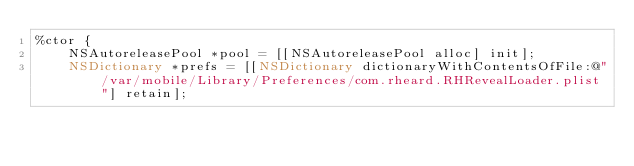<code> <loc_0><loc_0><loc_500><loc_500><_ObjectiveC_>%ctor {
    NSAutoreleasePool *pool = [[NSAutoreleasePool alloc] init];
    NSDictionary *prefs = [[NSDictionary dictionaryWithContentsOfFile:@"/var/mobile/Library/Preferences/com.rheard.RHRevealLoader.plist"] retain];</code> 